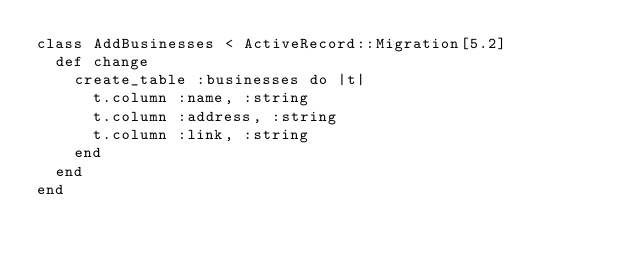Convert code to text. <code><loc_0><loc_0><loc_500><loc_500><_Ruby_>class AddBusinesses < ActiveRecord::Migration[5.2]
  def change
    create_table :businesses do |t|
      t.column :name, :string
      t.column :address, :string
      t.column :link, :string
    end
  end
end
</code> 